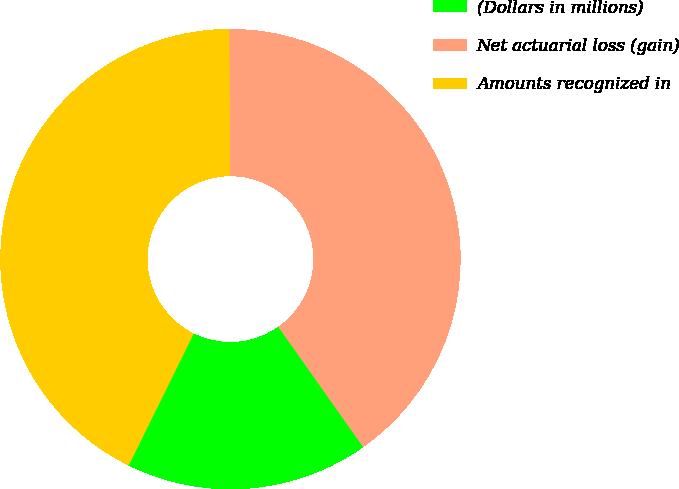<chart> <loc_0><loc_0><loc_500><loc_500><pie_chart><fcel>(Dollars in millions)<fcel>Net actuarial loss (gain)<fcel>Amounts recognized in<nl><fcel>17.08%<fcel>40.3%<fcel>42.63%<nl></chart> 